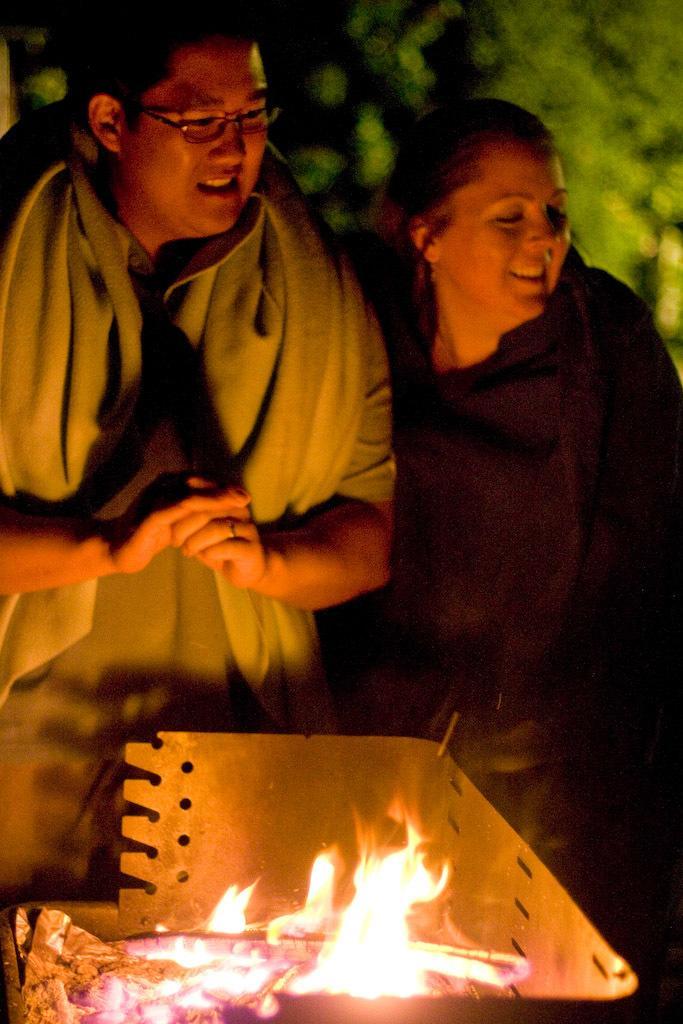In one or two sentences, can you explain what this image depicts? In this image we can see two people are standing, in front them there is some fire, in the background we can see some trees. 